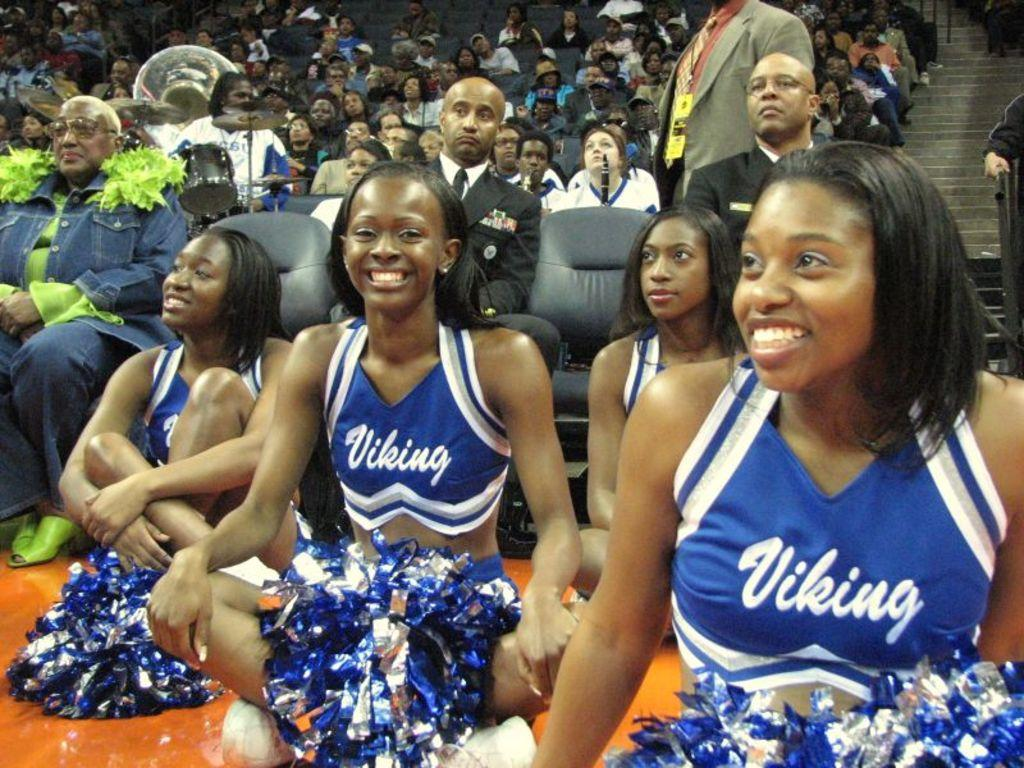<image>
Create a compact narrative representing the image presented. Four Viking cheerleaders sitting on a basketball court 